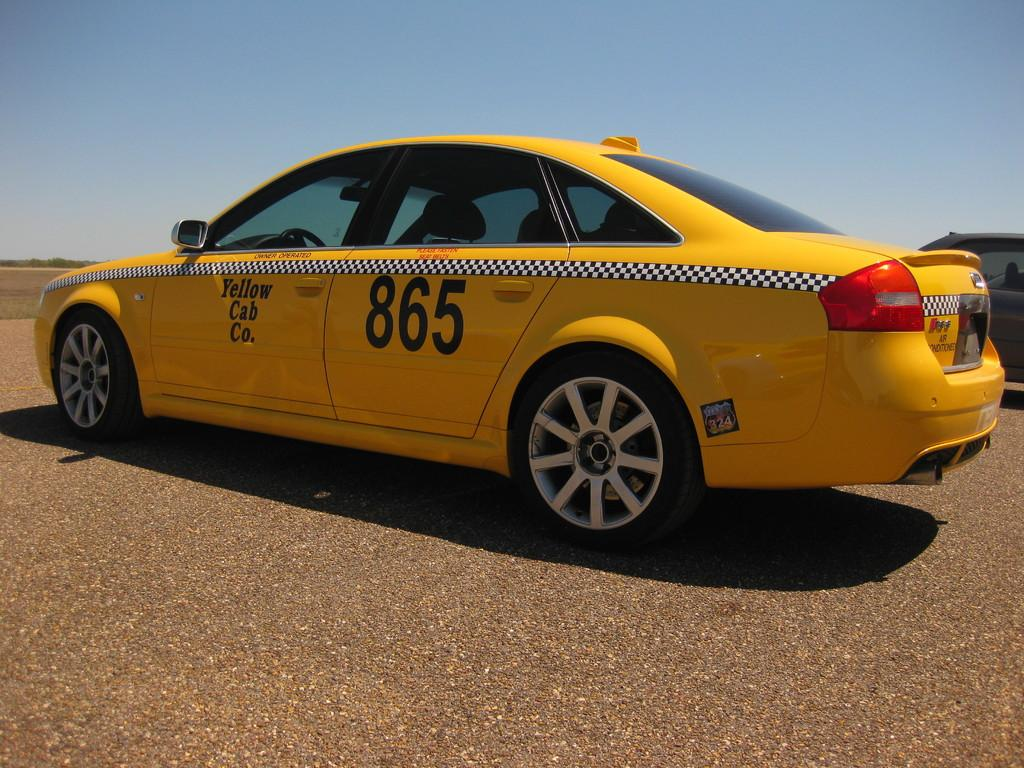<image>
Create a compact narrative representing the image presented. Yellow Cab number 865 is parked in a remote location. 